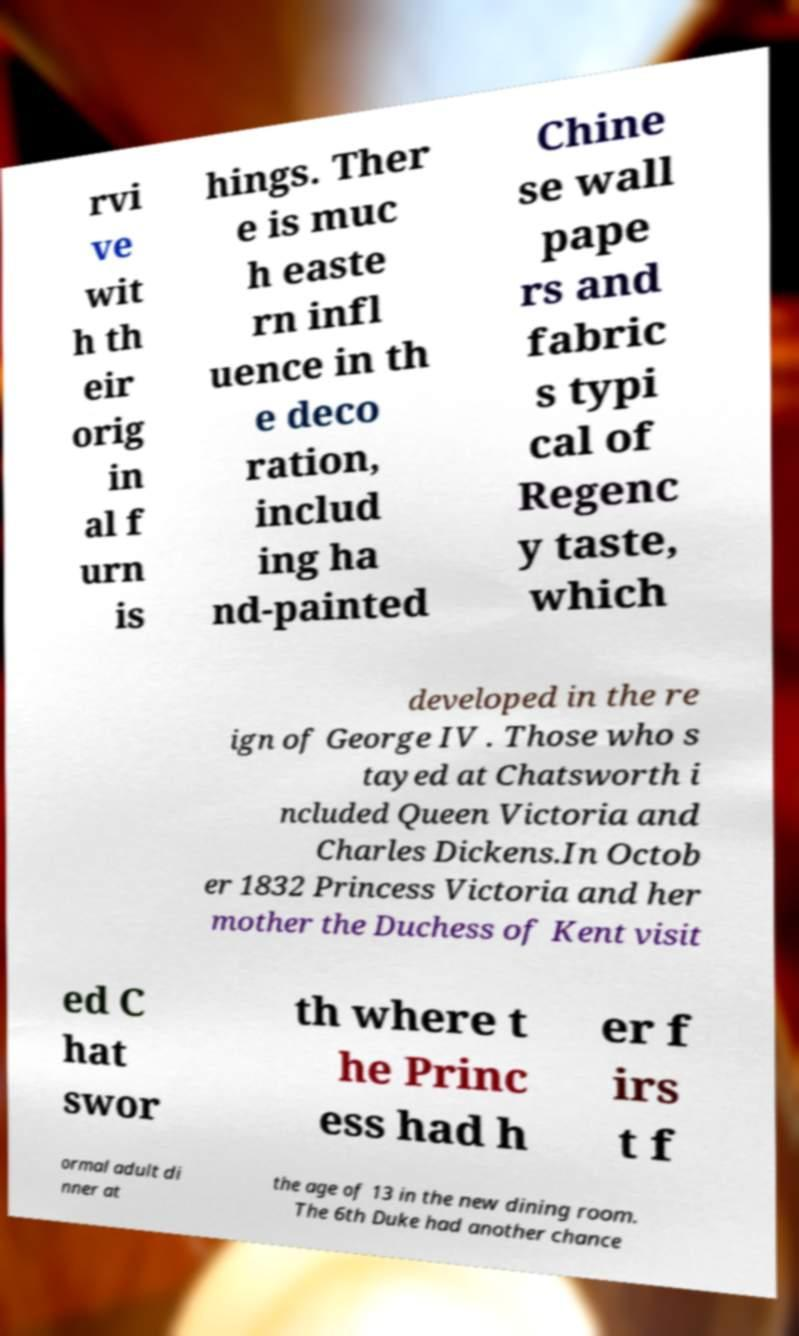Please read and relay the text visible in this image. What does it say? rvi ve wit h th eir orig in al f urn is hings. Ther e is muc h easte rn infl uence in th e deco ration, includ ing ha nd-painted Chine se wall pape rs and fabric s typi cal of Regenc y taste, which developed in the re ign of George IV . Those who s tayed at Chatsworth i ncluded Queen Victoria and Charles Dickens.In Octob er 1832 Princess Victoria and her mother the Duchess of Kent visit ed C hat swor th where t he Princ ess had h er f irs t f ormal adult di nner at the age of 13 in the new dining room. The 6th Duke had another chance 